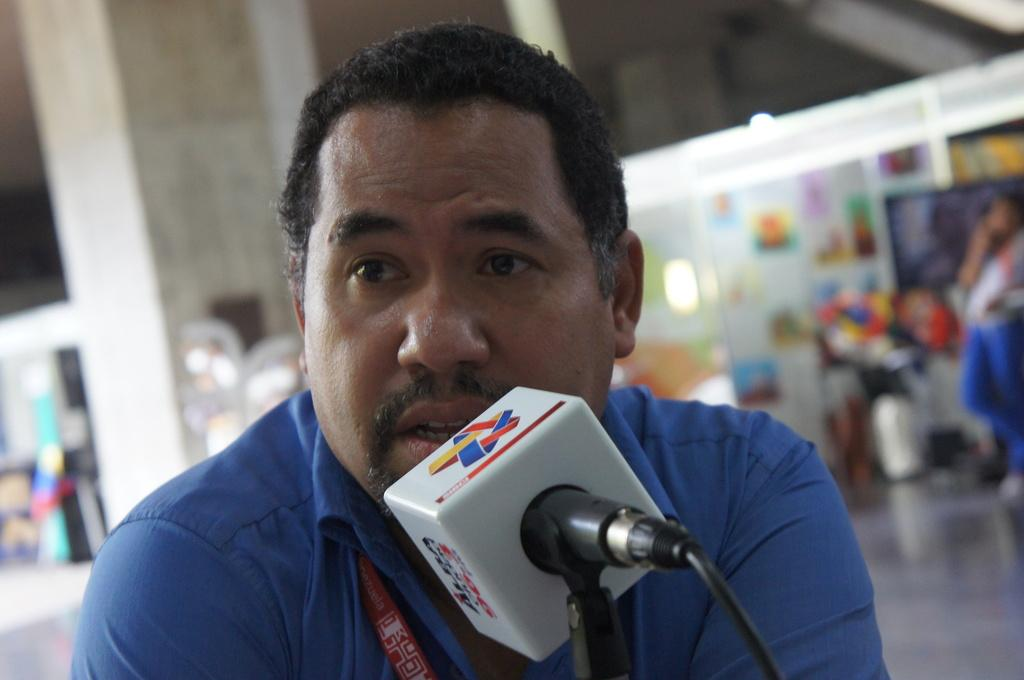Who is the person in the image? There is a man in the image. What is the man doing in the image? The man is speaking into a microphone. What color is the shirt the man is wearing? The man is wearing a blue shirt. What color is the microphone the man is using? The microphone is white. How many rabbits are hiding behind the man in the image? There are no rabbits present in the image. What type of roll is the man using to hold the microphone? The man is not using a roll to hold the microphone; he is simply speaking into it. 